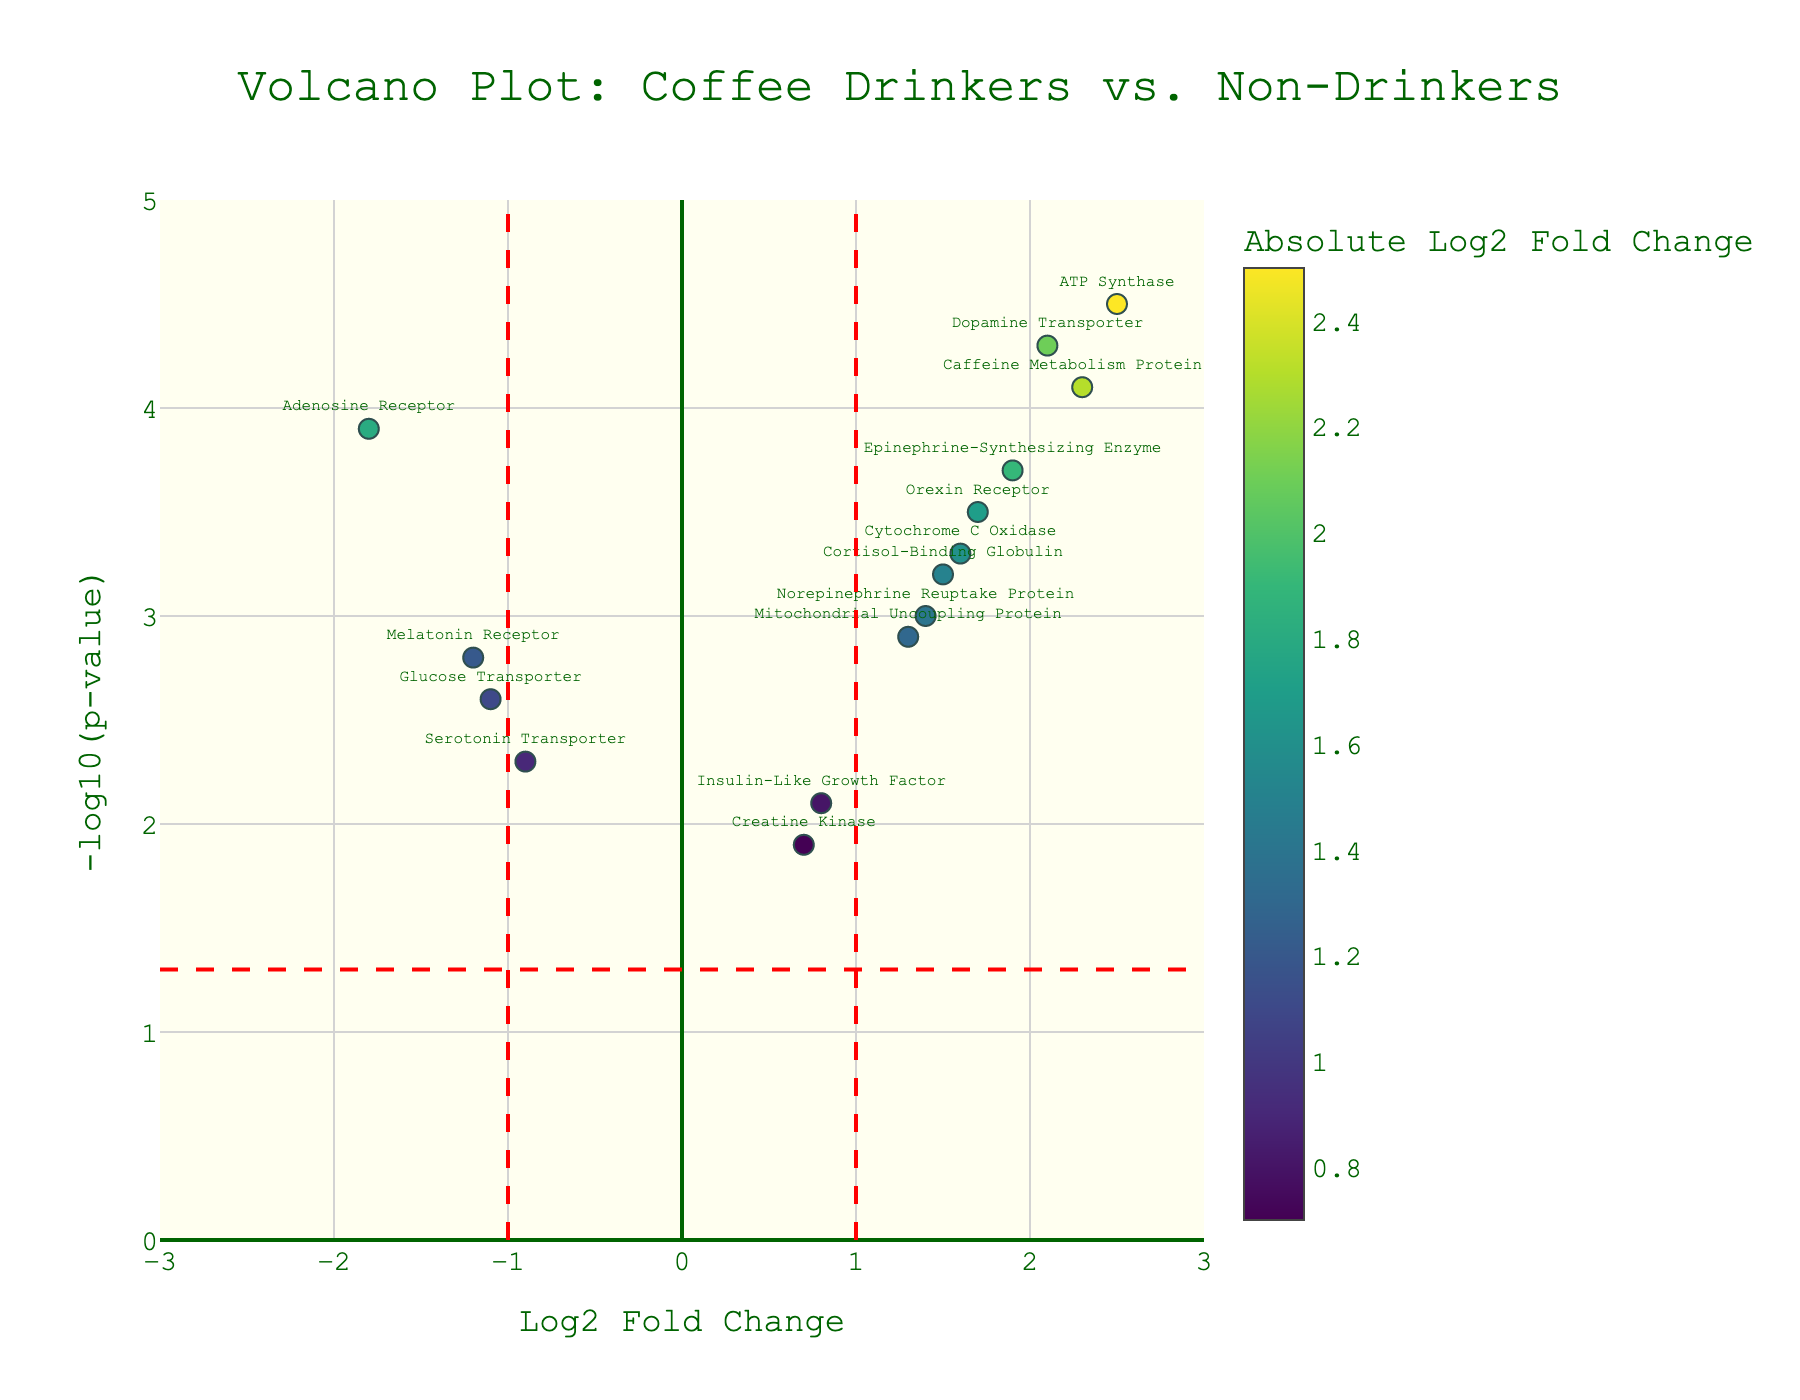What is the title of the plot? The title is usually displayed prominently at the top of the figure. In this case, it is included in the layout definition of the plot.
Answer: Volcano Plot: Coffee Drinkers vs. Non-Drinkers Which protein has the highest log2 fold change value? Identify the protein with the highest x-axis value in the figure.
Answer: ATP Synthase What's the threshold for the negative log10 p-value? The threshold line for the negative log10 p-value is marked in red and aligns horizontally at a specific value.
Answer: 1.3 Name a protein with a negative log2 fold change. Look for proteins plotted on the left side of the y-axis, where log2 fold change values are negative.
Answer: Adenosine Receptor How many proteins have a log2 fold change greater than 1? Count the number of data points to the right of the vertical threshold line at x = 1.
Answer: 8 Which protein is closest to the threshold line for the negative log10 p-value? Identify the data point closest to the red dashed line on the y-axis representing the threshold.
Answer: Orexin Receptor Compare the p-values of Dopamine Transporter and Caffeine Metabolism Protein 1. Which one is smaller? Check the y-axis values for both proteins and compare their heights. Higher values indicate smaller p-values.
Answer: Dopamine Transporter Which protein related to energy levels is not significantly altered in abundance between coffee drinkers and non-drinkers (assume significance threshold as p < 0.05 and log2FC > 1)? Look for proteins below the horizontal threshold line for p-value and within the two vertical threshold lines for log2 fold change.
Answer: Creatine Kinase What color represents proteins with higher absolute log2 fold change values? Colors in the figure are based on a color scale where higher absolute log2 fold changes are represented by colors on the upper end of the scale.
Answer: Darker colors (Viridis color scale) What's the log2 fold change and negative log10 p-value for Epinephrine-Synthesizing Enzyme? Locate the protein by its label and note its x (log2 fold change) and y (-log10 p-value) values.
Answer: Log2 Fold Change: 1.9, Negative Log10 P-Value: 3.7 